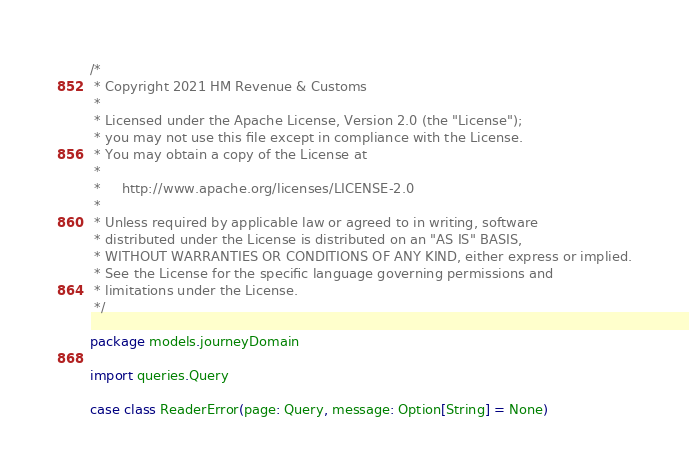Convert code to text. <code><loc_0><loc_0><loc_500><loc_500><_Scala_>/*
 * Copyright 2021 HM Revenue & Customs
 *
 * Licensed under the Apache License, Version 2.0 (the "License");
 * you may not use this file except in compliance with the License.
 * You may obtain a copy of the License at
 *
 *     http://www.apache.org/licenses/LICENSE-2.0
 *
 * Unless required by applicable law or agreed to in writing, software
 * distributed under the License is distributed on an "AS IS" BASIS,
 * WITHOUT WARRANTIES OR CONDITIONS OF ANY KIND, either express or implied.
 * See the License for the specific language governing permissions and
 * limitations under the License.
 */

package models.journeyDomain

import queries.Query

case class ReaderError(page: Query, message: Option[String] = None)
</code> 